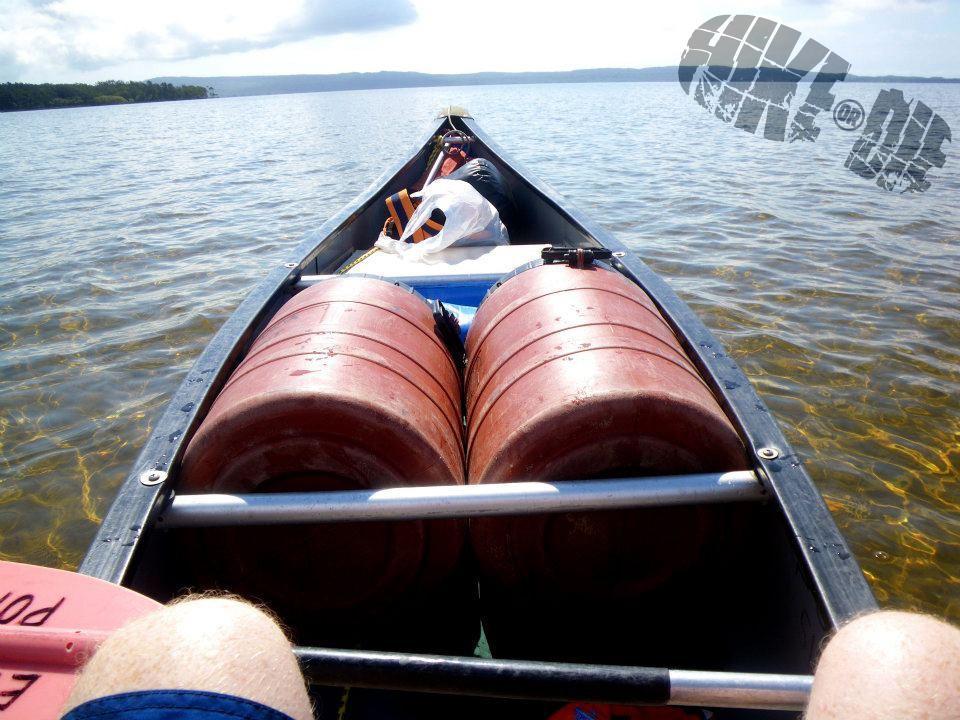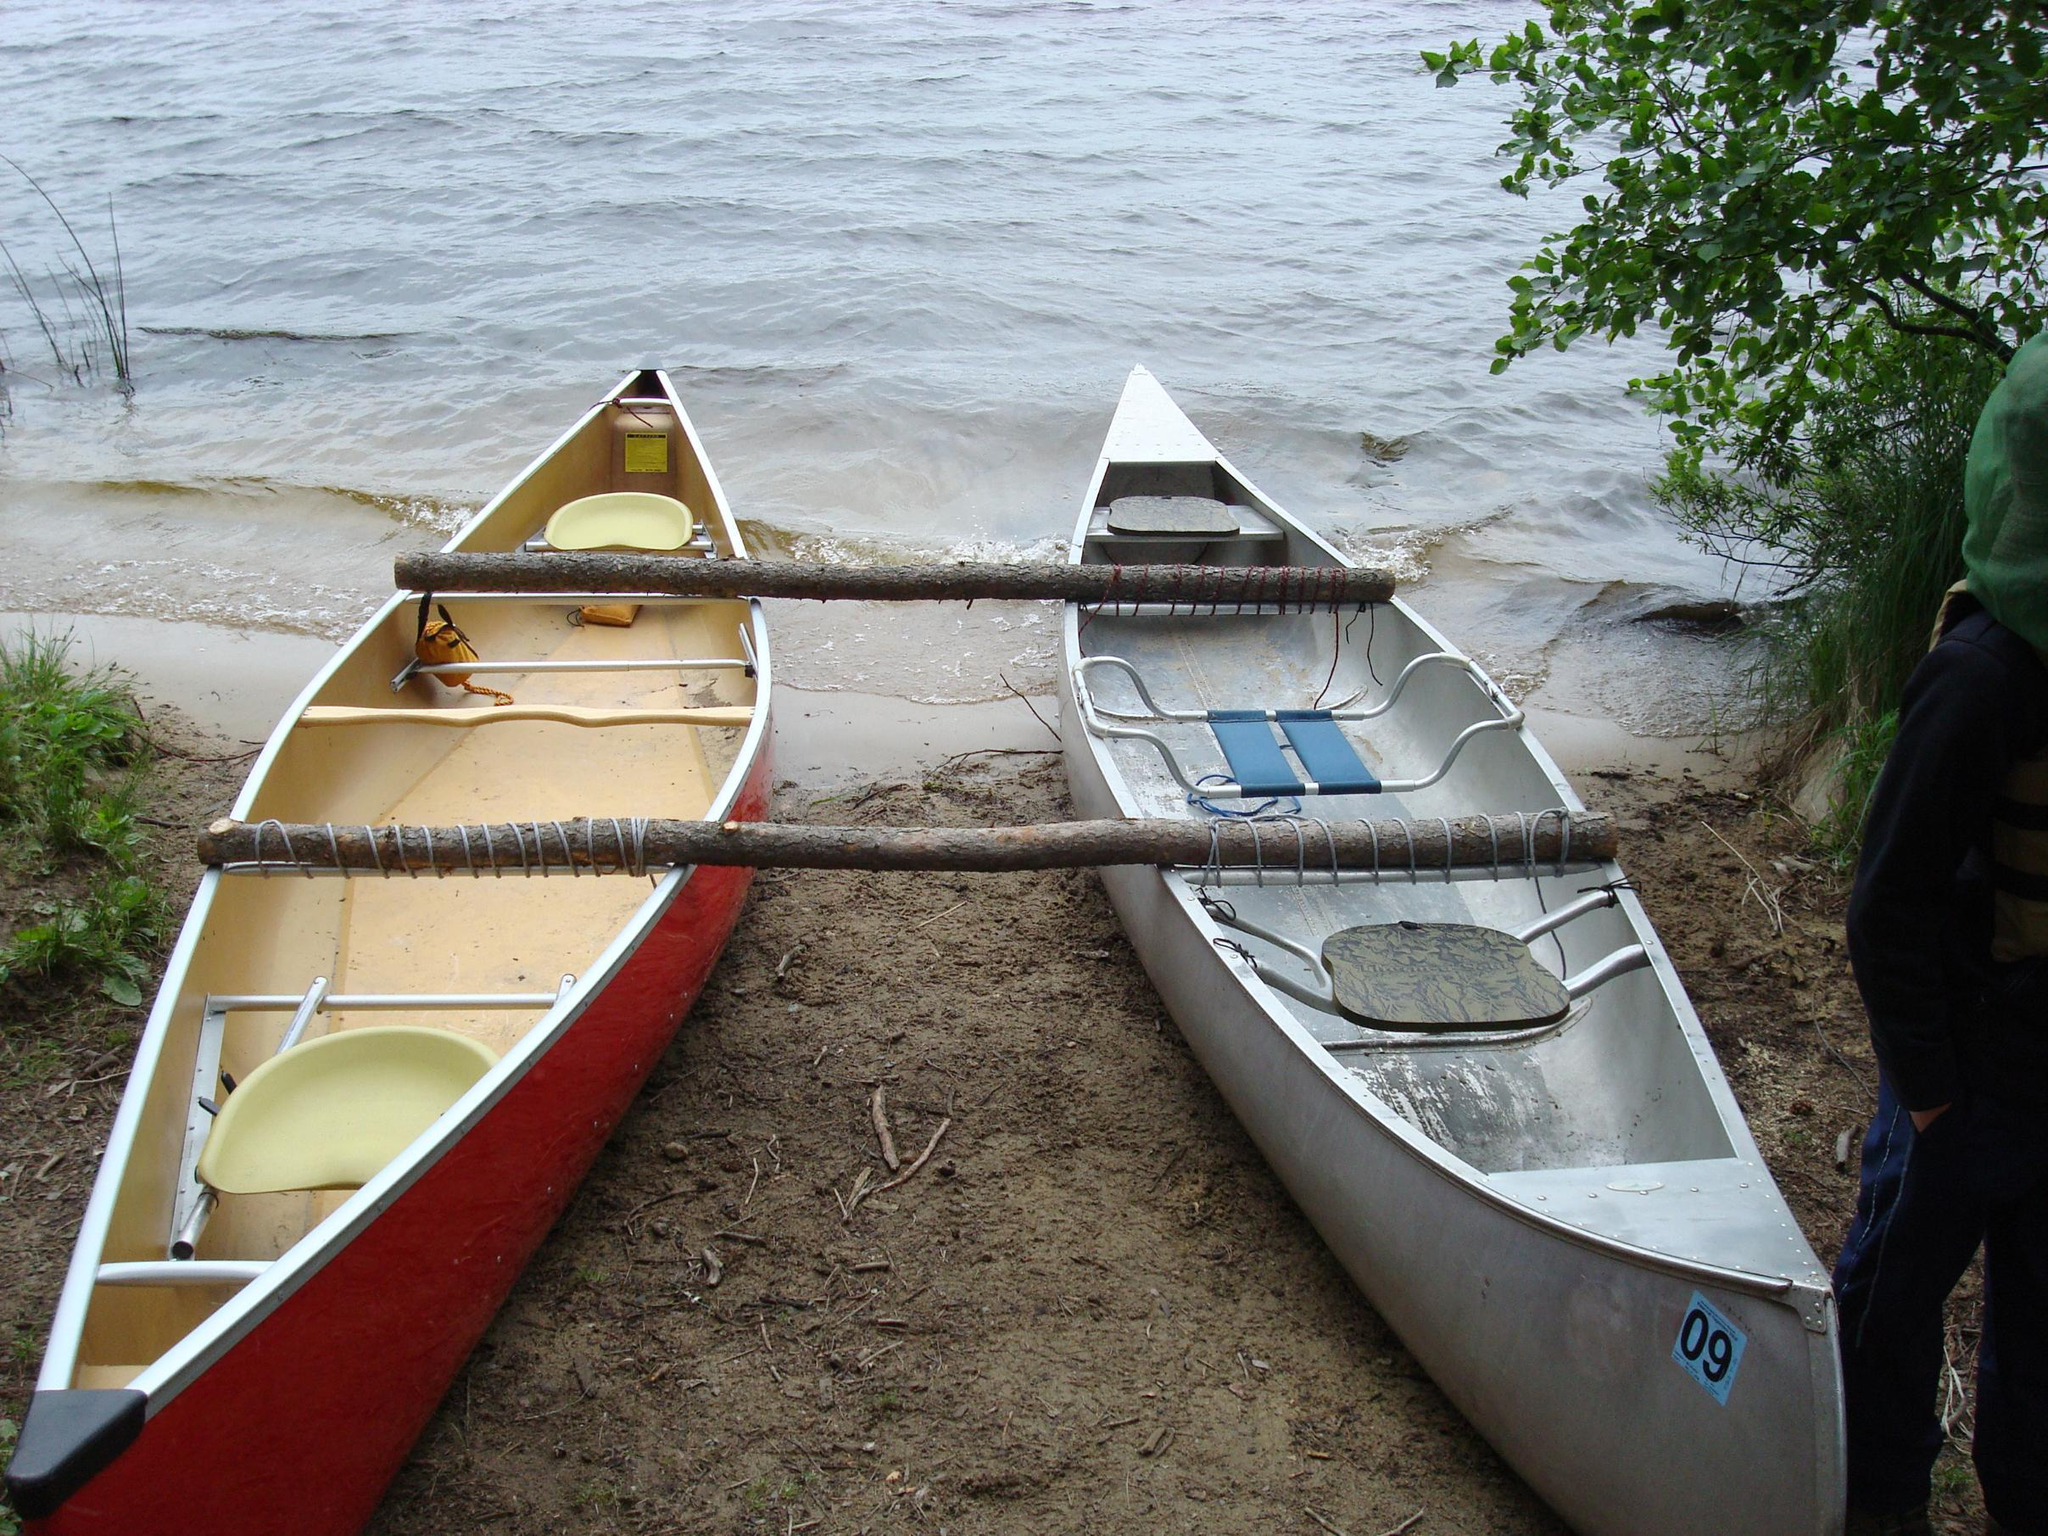The first image is the image on the left, the second image is the image on the right. Analyze the images presented: Is the assertion "One image shows side-by-side canoes joined with just two simple poles and not floating on water." valid? Answer yes or no. Yes. The first image is the image on the left, the second image is the image on the right. Assess this claim about the two images: "There are a minimum of four boats.". Correct or not? Answer yes or no. No. 